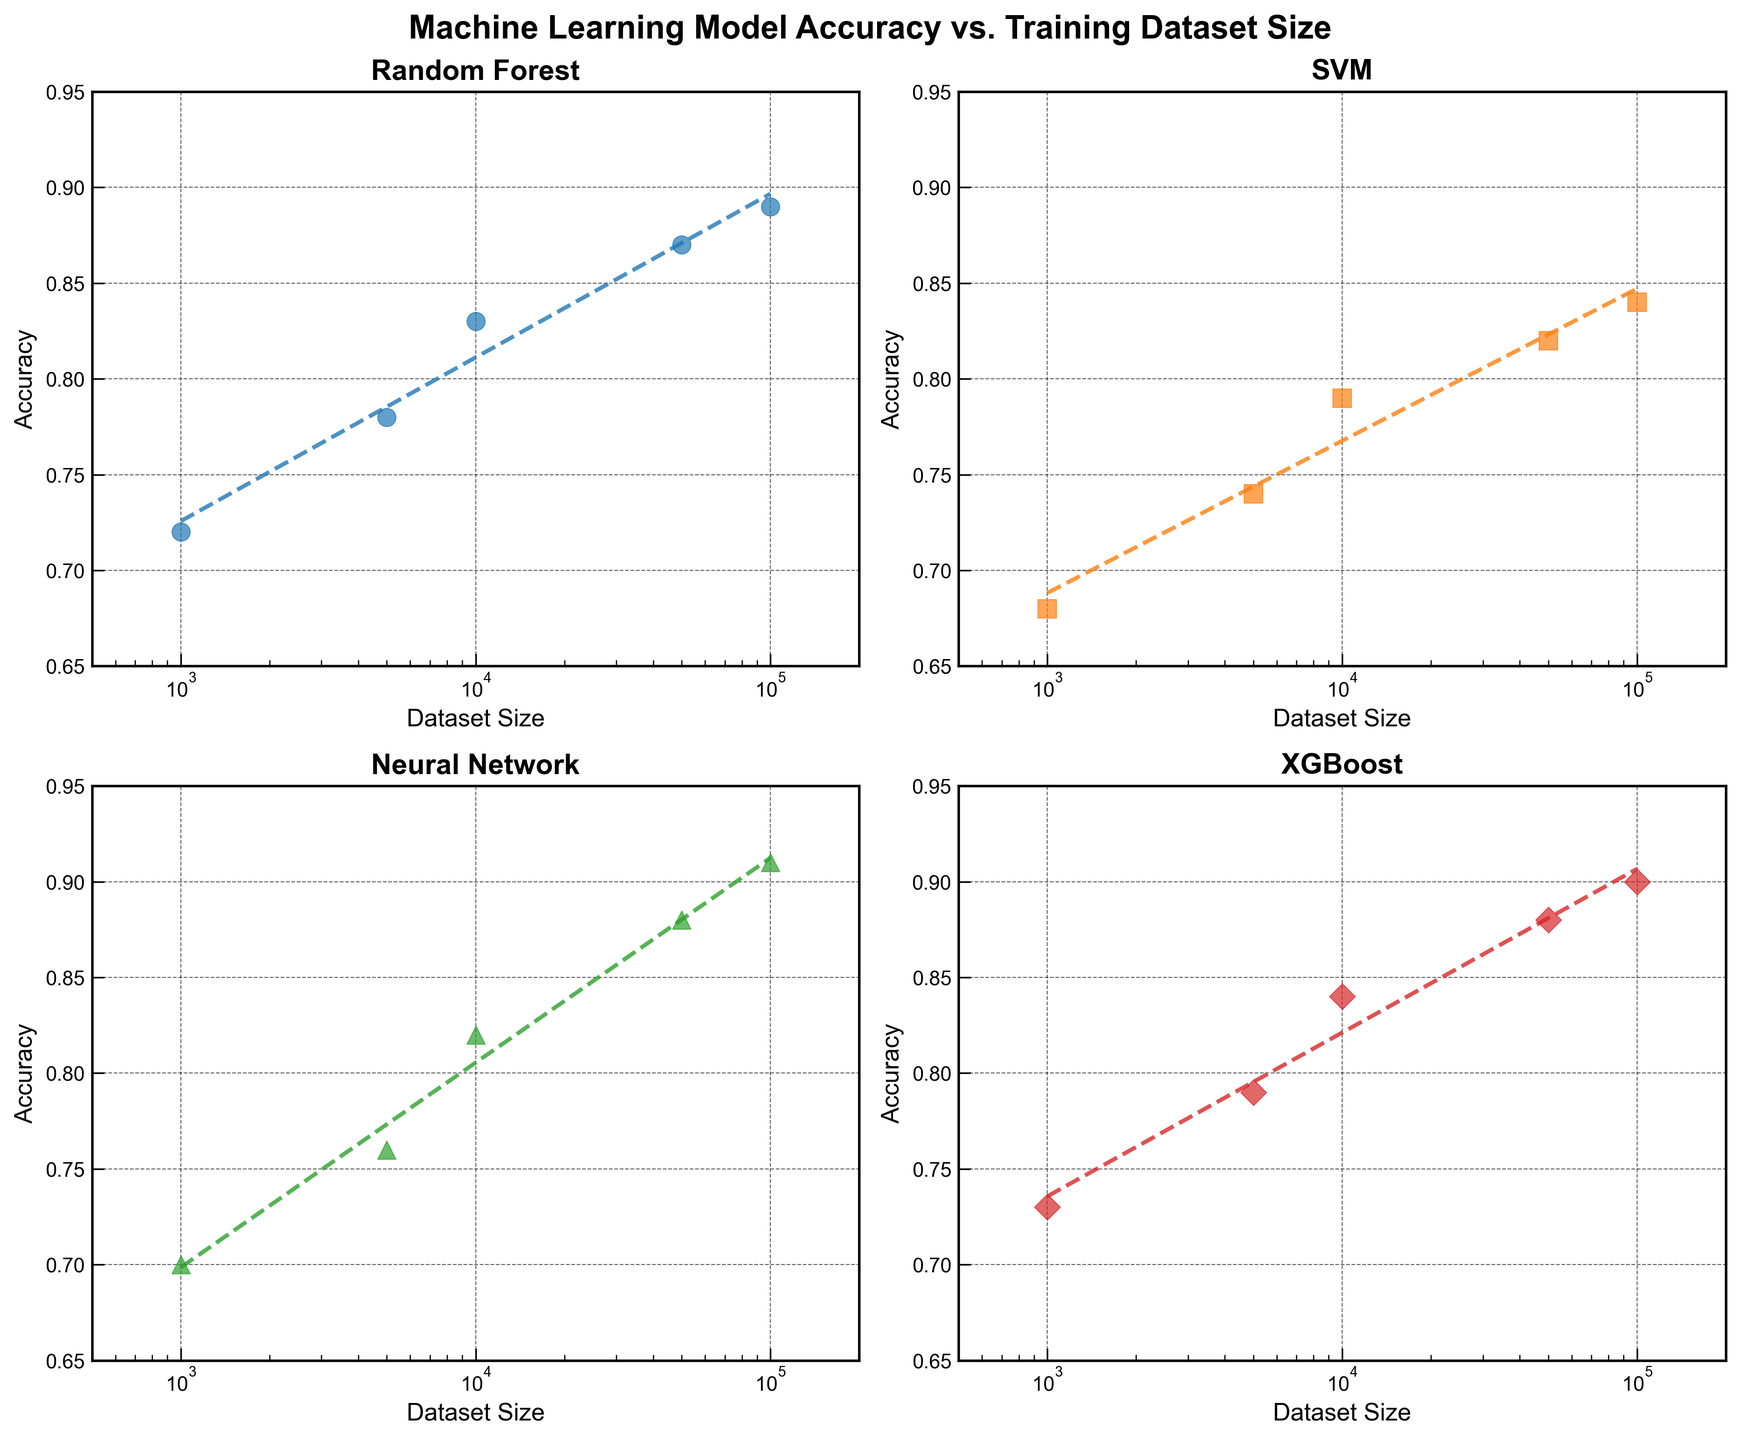What is the title of the figure? The title of the figure is displayed at the top and provides the overall topic of the plot. It is: "Machine Learning Model Accuracy vs. Training Dataset Size"
Answer: Machine Learning Model Accuracy vs. Training Dataset Size What is the maximum accuracy value achieved by the Neural Network algorithm? The Neural Network subplot shows the accuracy values. The highest point on its scatter plot reaches 0.91.
Answer: 0.91 Which algorithm shows the highest improvement in accuracy with increasing dataset size? By comparing the slopes of the trend lines across all algorithm subplots, the Neural Network algorithm has the steepest increase in accuracy with dataset size.
Answer: Neural Network At a dataset size of 100,000, which algorithm has the lowest accuracy? Looking at the data points at 100,000 datasets size across all subplots, SVM has the lowest accuracy, which is 0.84.
Answer: SVM What is the approximate difference in accuracy between XGBoost and Random Forest for a dataset size of 10,000? By looking at the data points for a dataset size of 10,000, XGBoost has an accuracy of 0.84 and Random Forest has 0.83. The difference is 0.84 - 0.83 = 0.01.
Answer: 0.01 Which algorithm's accuracy appears to converge the fastest as the dataset size increases? Observing the plots, the SVM algorithm’s accuracy line flattens out sooner than the others as dataset size increases, indicating faster convergence.
Answer: SVM Does any of the algorithms reach an accuracy of 0.90? By examining the highest points in all subplots, only Neural Network and XGBoost reach or surpass an accuracy of 0.90.
Answer: Neural Network, XGBoost On a logarithmic scale, which algorithm shows the most linear progression of accuracy with increasing dataset size? By comparing the linearity of the fit lines on the log scale, Neural Network's progression appears to be the most linear.
Answer: Neural Network 